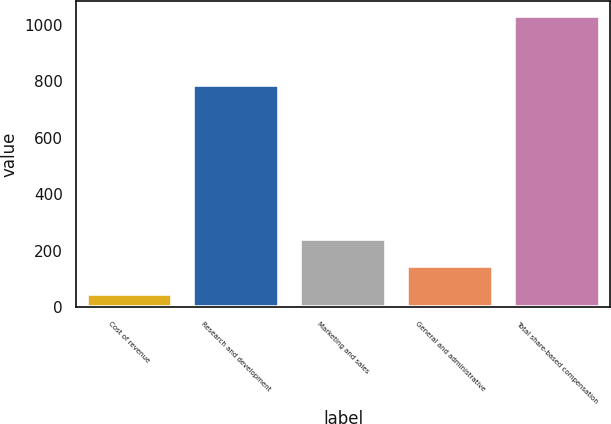Convert chart to OTSL. <chart><loc_0><loc_0><loc_500><loc_500><bar_chart><fcel>Cost of revenue<fcel>Research and development<fcel>Marketing and sales<fcel>General and administrative<fcel>Total share-based compensation<nl><fcel>47<fcel>787<fcel>244<fcel>145.5<fcel>1032<nl></chart> 